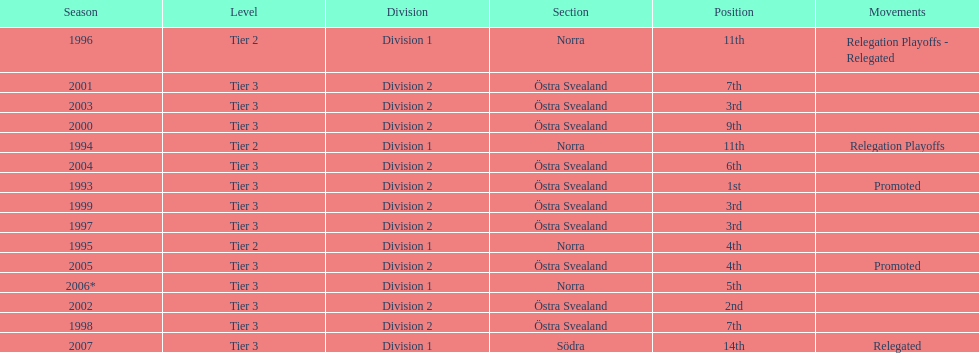How many times did they finish above 5th place in division 2 tier 3? 6. 